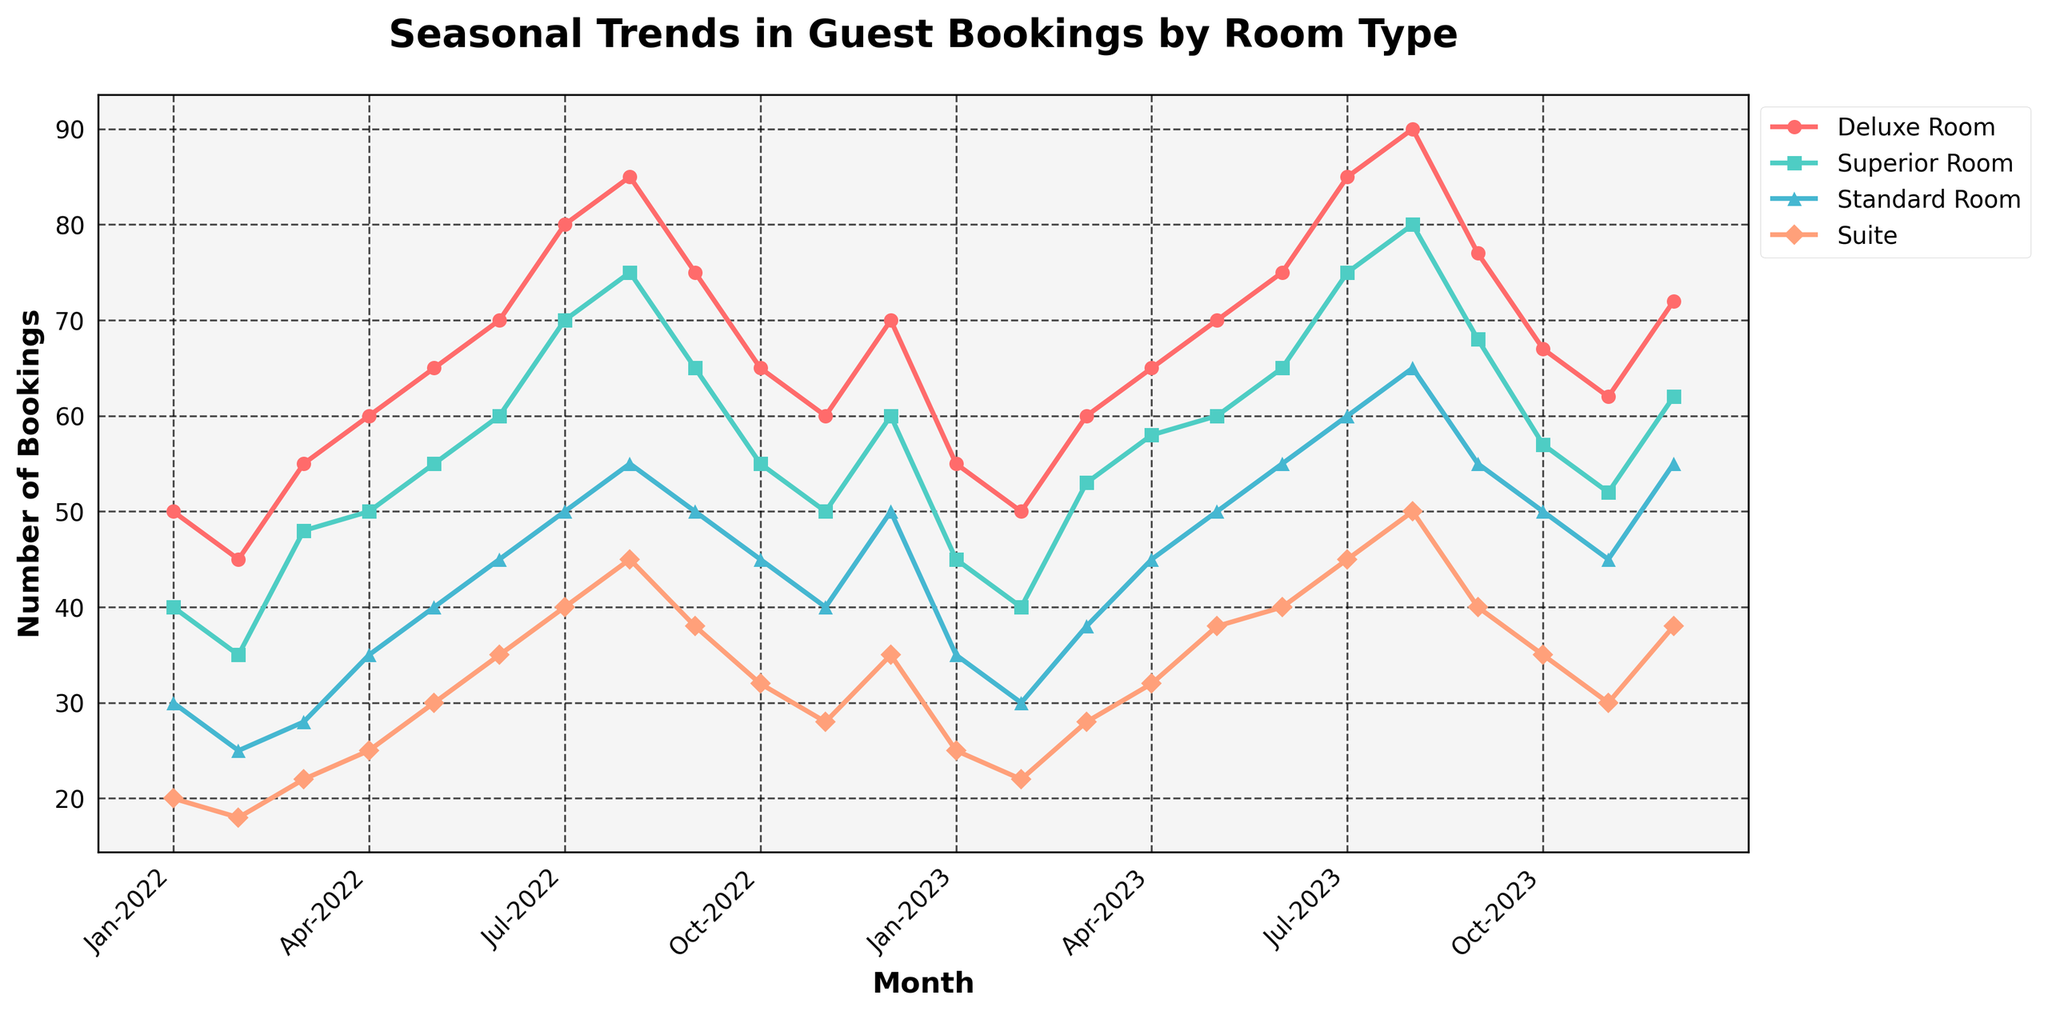What is the title of the figure? The title is usually placed at the top of the figure and is often bold and larger in font size. By reading the title, one can understand the main subject of the figure.
Answer: Seasonal Trends in Guest Bookings by Room Type What month shows the highest number of bookings for the Superior Room in 2022? Look at the curve labeled "Superior Room" and identify which point has the highest value in 2022. Checking each month, August shows the highest.
Answer: August 2022 What's the general trend in bookings for the Deluxe Room from January 2022 to December 2023? Observing the curve labeled "Deluxe Room", you can see it generally increases toward the end of 2023 except for slight declines in early months and late 2022.
Answer: Increasing trend Which room type had the least variation in bookings over the shown period? Identify which curve has the smallest fluctuations from its minimum to maximum values. The "Standard Room" curve appears to have the least fluctuation.
Answer: Standard Room How many bookings were there for all room types combined in December 2023? Sum the bookings for each room type in December 2023: Deluxe Room (72) + Superior Room (62) + Standard Room (55) + Suite (38).
Answer: 227 In which month and year did the Suite room bookings first reach 40? Scan the curve for "Suite" and find the first point where bookings reach 40.
Answer: July 2022 Between which two consecutive months did the Deluxe Room bookings increase the most? Identify the largest vertical jump between two points on the "Deluxe Room" curve. The largest increase is from January 2023 to February 2023 (77 - 72 = 5).
Answer: January 2022 to February 2022 How did the bookings for the Suite room change from August 2023 to September 2023? Look at the "Suite" curve in August and September 2023 to see the change in bookings: it decreased from 50 to 45.
Answer: Decreased What is the average number of bookings for the Superior Room in 2023? Compute the average: add all 2023 Superior Room bookings and divide by 12: (45 + 40 + 53 + 58 + 60 + 65 + 75 + 80 + 68 + 57 + 52 + 62) / 12.
Answer: 59.08 In which season (Winter, Spring, Summer, Fall) did the Deluxe Room have the highest average bookings in 2023? Determine the average bookings for each season. Winter (Jan, Feb, Dec): (45 + 40 + 62) / 3 = 49.00, Spring (Mar, Apr, May): (53 + 58 + 60) / 3 = 57.00, Summer (Jun, Jul, Aug): (65 + 75 + 80) / 3 = 73.33, Fall (Sep, Oct, Nov): (68 + 57 + 52) / 3 = 59.00.
Answer: Summer 